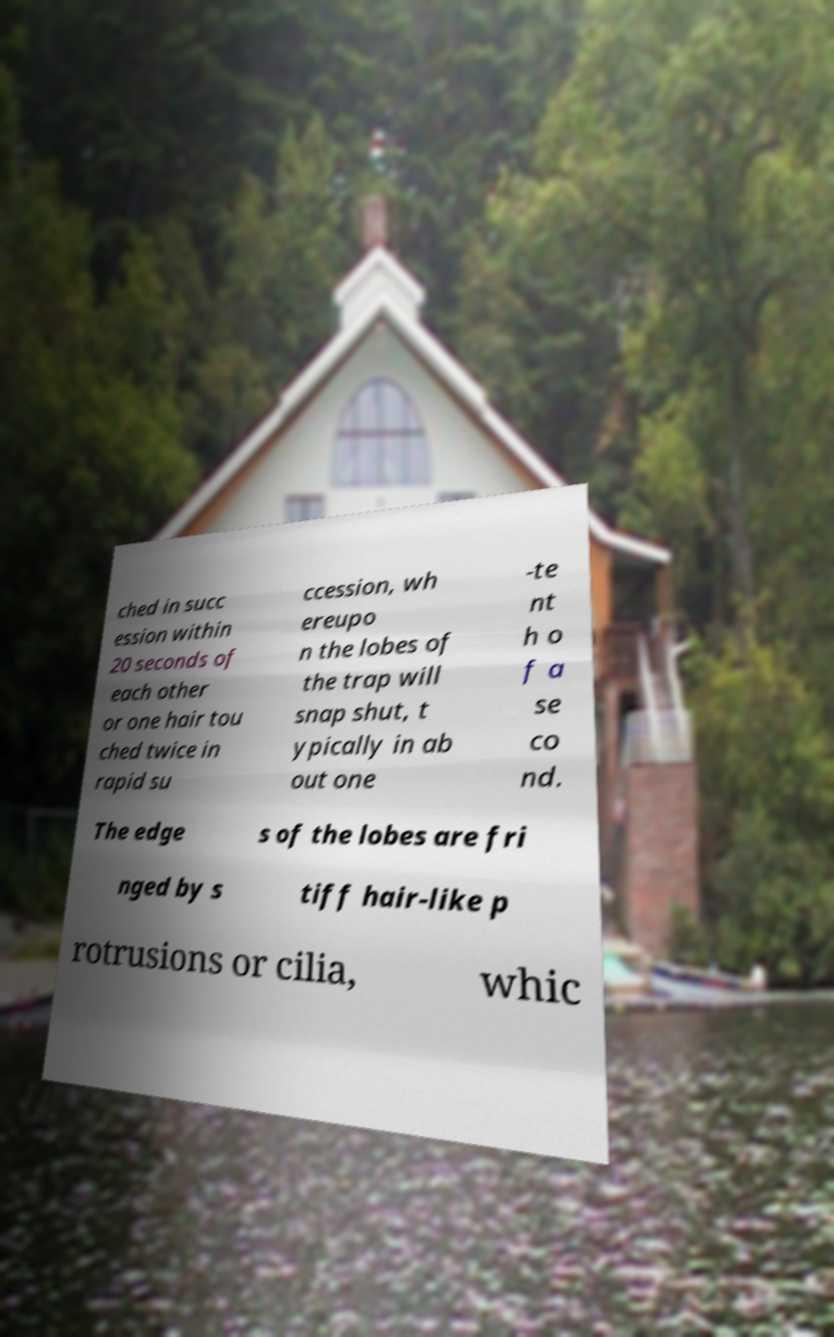Please identify and transcribe the text found in this image. ched in succ ession within 20 seconds of each other or one hair tou ched twice in rapid su ccession, wh ereupo n the lobes of the trap will snap shut, t ypically in ab out one -te nt h o f a se co nd. The edge s of the lobes are fri nged by s tiff hair-like p rotrusions or cilia, whic 